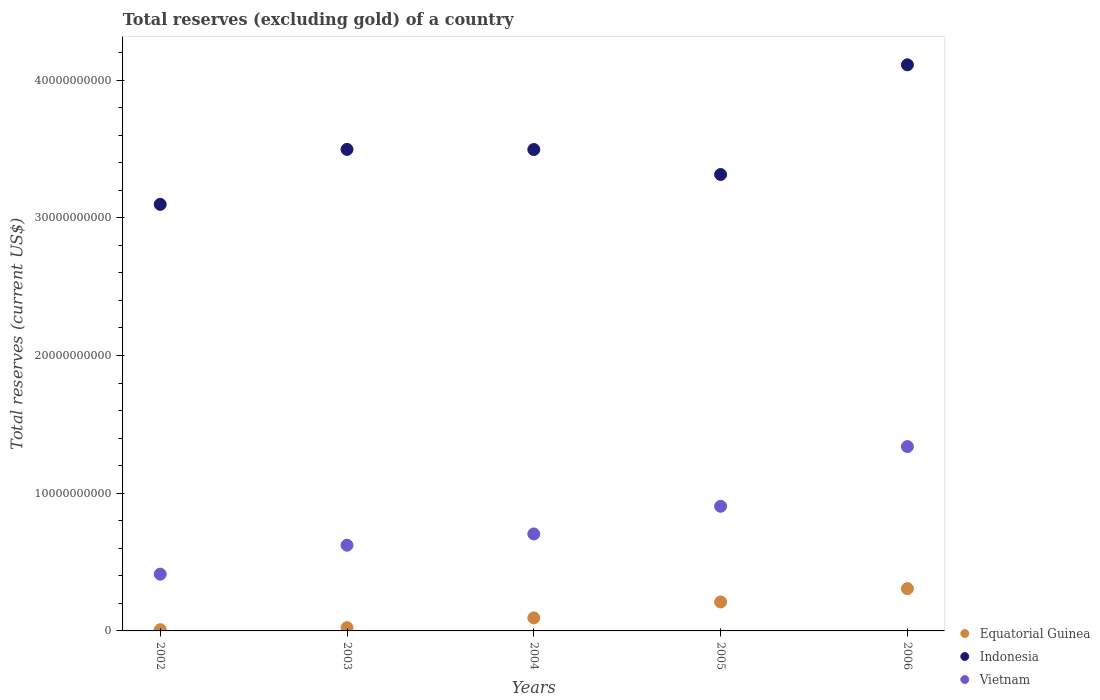How many different coloured dotlines are there?
Offer a terse response. 3. Is the number of dotlines equal to the number of legend labels?
Offer a terse response. Yes. What is the total reserves (excluding gold) in Vietnam in 2003?
Make the answer very short. 6.22e+09. Across all years, what is the maximum total reserves (excluding gold) in Equatorial Guinea?
Provide a succinct answer. 3.07e+09. Across all years, what is the minimum total reserves (excluding gold) in Vietnam?
Your answer should be very brief. 4.12e+09. What is the total total reserves (excluding gold) in Equatorial Guinea in the graph?
Offer a very short reply. 6.44e+09. What is the difference between the total reserves (excluding gold) in Indonesia in 2002 and that in 2004?
Ensure brevity in your answer.  -3.98e+09. What is the difference between the total reserves (excluding gold) in Vietnam in 2002 and the total reserves (excluding gold) in Equatorial Guinea in 2003?
Your response must be concise. 3.88e+09. What is the average total reserves (excluding gold) in Equatorial Guinea per year?
Offer a terse response. 1.29e+09. In the year 2003, what is the difference between the total reserves (excluding gold) in Vietnam and total reserves (excluding gold) in Equatorial Guinea?
Your answer should be very brief. 5.99e+09. In how many years, is the total reserves (excluding gold) in Vietnam greater than 4000000000 US$?
Offer a very short reply. 5. What is the ratio of the total reserves (excluding gold) in Equatorial Guinea in 2002 to that in 2003?
Provide a succinct answer. 0.37. Is the total reserves (excluding gold) in Equatorial Guinea in 2003 less than that in 2005?
Offer a terse response. Yes. What is the difference between the highest and the second highest total reserves (excluding gold) in Indonesia?
Ensure brevity in your answer.  6.14e+09. What is the difference between the highest and the lowest total reserves (excluding gold) in Equatorial Guinea?
Make the answer very short. 2.98e+09. In how many years, is the total reserves (excluding gold) in Equatorial Guinea greater than the average total reserves (excluding gold) in Equatorial Guinea taken over all years?
Give a very brief answer. 2. Is the sum of the total reserves (excluding gold) in Equatorial Guinea in 2002 and 2006 greater than the maximum total reserves (excluding gold) in Vietnam across all years?
Ensure brevity in your answer.  No. Is it the case that in every year, the sum of the total reserves (excluding gold) in Equatorial Guinea and total reserves (excluding gold) in Vietnam  is greater than the total reserves (excluding gold) in Indonesia?
Provide a short and direct response. No. Does the total reserves (excluding gold) in Vietnam monotonically increase over the years?
Give a very brief answer. Yes. Is the total reserves (excluding gold) in Equatorial Guinea strictly less than the total reserves (excluding gold) in Indonesia over the years?
Keep it short and to the point. Yes. How many years are there in the graph?
Give a very brief answer. 5. Are the values on the major ticks of Y-axis written in scientific E-notation?
Ensure brevity in your answer.  No. Does the graph contain any zero values?
Provide a succinct answer. No. Where does the legend appear in the graph?
Make the answer very short. Bottom right. How many legend labels are there?
Provide a succinct answer. 3. How are the legend labels stacked?
Provide a succinct answer. Vertical. What is the title of the graph?
Provide a succinct answer. Total reserves (excluding gold) of a country. What is the label or title of the X-axis?
Give a very brief answer. Years. What is the label or title of the Y-axis?
Give a very brief answer. Total reserves (current US$). What is the Total reserves (current US$) of Equatorial Guinea in 2002?
Provide a short and direct response. 8.85e+07. What is the Total reserves (current US$) in Indonesia in 2002?
Your response must be concise. 3.10e+1. What is the Total reserves (current US$) in Vietnam in 2002?
Your answer should be very brief. 4.12e+09. What is the Total reserves (current US$) of Equatorial Guinea in 2003?
Your answer should be very brief. 2.38e+08. What is the Total reserves (current US$) in Indonesia in 2003?
Offer a terse response. 3.50e+1. What is the Total reserves (current US$) in Vietnam in 2003?
Provide a succinct answer. 6.22e+09. What is the Total reserves (current US$) of Equatorial Guinea in 2004?
Keep it short and to the point. 9.45e+08. What is the Total reserves (current US$) in Indonesia in 2004?
Ensure brevity in your answer.  3.50e+1. What is the Total reserves (current US$) in Vietnam in 2004?
Keep it short and to the point. 7.04e+09. What is the Total reserves (current US$) in Equatorial Guinea in 2005?
Provide a succinct answer. 2.10e+09. What is the Total reserves (current US$) in Indonesia in 2005?
Make the answer very short. 3.31e+1. What is the Total reserves (current US$) in Vietnam in 2005?
Ensure brevity in your answer.  9.05e+09. What is the Total reserves (current US$) of Equatorial Guinea in 2006?
Give a very brief answer. 3.07e+09. What is the Total reserves (current US$) of Indonesia in 2006?
Provide a short and direct response. 4.11e+1. What is the Total reserves (current US$) in Vietnam in 2006?
Provide a succinct answer. 1.34e+1. Across all years, what is the maximum Total reserves (current US$) in Equatorial Guinea?
Make the answer very short. 3.07e+09. Across all years, what is the maximum Total reserves (current US$) in Indonesia?
Your answer should be very brief. 4.11e+1. Across all years, what is the maximum Total reserves (current US$) of Vietnam?
Keep it short and to the point. 1.34e+1. Across all years, what is the minimum Total reserves (current US$) in Equatorial Guinea?
Your response must be concise. 8.85e+07. Across all years, what is the minimum Total reserves (current US$) of Indonesia?
Offer a very short reply. 3.10e+1. Across all years, what is the minimum Total reserves (current US$) in Vietnam?
Provide a short and direct response. 4.12e+09. What is the total Total reserves (current US$) in Equatorial Guinea in the graph?
Offer a very short reply. 6.44e+09. What is the total Total reserves (current US$) of Indonesia in the graph?
Provide a succinct answer. 1.75e+11. What is the total Total reserves (current US$) of Vietnam in the graph?
Offer a terse response. 3.98e+1. What is the difference between the Total reserves (current US$) of Equatorial Guinea in 2002 and that in 2003?
Give a very brief answer. -1.49e+08. What is the difference between the Total reserves (current US$) of Indonesia in 2002 and that in 2003?
Your answer should be very brief. -3.99e+09. What is the difference between the Total reserves (current US$) of Vietnam in 2002 and that in 2003?
Your answer should be compact. -2.10e+09. What is the difference between the Total reserves (current US$) of Equatorial Guinea in 2002 and that in 2004?
Keep it short and to the point. -8.56e+08. What is the difference between the Total reserves (current US$) in Indonesia in 2002 and that in 2004?
Provide a succinct answer. -3.98e+09. What is the difference between the Total reserves (current US$) in Vietnam in 2002 and that in 2004?
Give a very brief answer. -2.92e+09. What is the difference between the Total reserves (current US$) of Equatorial Guinea in 2002 and that in 2005?
Give a very brief answer. -2.01e+09. What is the difference between the Total reserves (current US$) of Indonesia in 2002 and that in 2005?
Give a very brief answer. -2.17e+09. What is the difference between the Total reserves (current US$) in Vietnam in 2002 and that in 2005?
Keep it short and to the point. -4.93e+09. What is the difference between the Total reserves (current US$) in Equatorial Guinea in 2002 and that in 2006?
Offer a very short reply. -2.98e+09. What is the difference between the Total reserves (current US$) in Indonesia in 2002 and that in 2006?
Provide a short and direct response. -1.01e+1. What is the difference between the Total reserves (current US$) of Vietnam in 2002 and that in 2006?
Make the answer very short. -9.26e+09. What is the difference between the Total reserves (current US$) in Equatorial Guinea in 2003 and that in 2004?
Make the answer very short. -7.07e+08. What is the difference between the Total reserves (current US$) in Indonesia in 2003 and that in 2004?
Offer a terse response. 9.82e+06. What is the difference between the Total reserves (current US$) in Vietnam in 2003 and that in 2004?
Keep it short and to the point. -8.17e+08. What is the difference between the Total reserves (current US$) in Equatorial Guinea in 2003 and that in 2005?
Offer a very short reply. -1.86e+09. What is the difference between the Total reserves (current US$) in Indonesia in 2003 and that in 2005?
Offer a very short reply. 1.82e+09. What is the difference between the Total reserves (current US$) of Vietnam in 2003 and that in 2005?
Make the answer very short. -2.83e+09. What is the difference between the Total reserves (current US$) of Equatorial Guinea in 2003 and that in 2006?
Keep it short and to the point. -2.83e+09. What is the difference between the Total reserves (current US$) of Indonesia in 2003 and that in 2006?
Make the answer very short. -6.14e+09. What is the difference between the Total reserves (current US$) in Vietnam in 2003 and that in 2006?
Ensure brevity in your answer.  -7.16e+09. What is the difference between the Total reserves (current US$) of Equatorial Guinea in 2004 and that in 2005?
Keep it short and to the point. -1.16e+09. What is the difference between the Total reserves (current US$) in Indonesia in 2004 and that in 2005?
Offer a terse response. 1.81e+09. What is the difference between the Total reserves (current US$) in Vietnam in 2004 and that in 2005?
Keep it short and to the point. -2.01e+09. What is the difference between the Total reserves (current US$) of Equatorial Guinea in 2004 and that in 2006?
Provide a short and direct response. -2.12e+09. What is the difference between the Total reserves (current US$) in Indonesia in 2004 and that in 2006?
Ensure brevity in your answer.  -6.15e+09. What is the difference between the Total reserves (current US$) of Vietnam in 2004 and that in 2006?
Make the answer very short. -6.34e+09. What is the difference between the Total reserves (current US$) in Equatorial Guinea in 2005 and that in 2006?
Offer a terse response. -9.64e+08. What is the difference between the Total reserves (current US$) in Indonesia in 2005 and that in 2006?
Your answer should be compact. -7.96e+09. What is the difference between the Total reserves (current US$) in Vietnam in 2005 and that in 2006?
Provide a succinct answer. -4.33e+09. What is the difference between the Total reserves (current US$) in Equatorial Guinea in 2002 and the Total reserves (current US$) in Indonesia in 2003?
Ensure brevity in your answer.  -3.49e+1. What is the difference between the Total reserves (current US$) of Equatorial Guinea in 2002 and the Total reserves (current US$) of Vietnam in 2003?
Keep it short and to the point. -6.14e+09. What is the difference between the Total reserves (current US$) of Indonesia in 2002 and the Total reserves (current US$) of Vietnam in 2003?
Your response must be concise. 2.47e+1. What is the difference between the Total reserves (current US$) of Equatorial Guinea in 2002 and the Total reserves (current US$) of Indonesia in 2004?
Provide a short and direct response. -3.49e+1. What is the difference between the Total reserves (current US$) of Equatorial Guinea in 2002 and the Total reserves (current US$) of Vietnam in 2004?
Provide a short and direct response. -6.95e+09. What is the difference between the Total reserves (current US$) in Indonesia in 2002 and the Total reserves (current US$) in Vietnam in 2004?
Your response must be concise. 2.39e+1. What is the difference between the Total reserves (current US$) of Equatorial Guinea in 2002 and the Total reserves (current US$) of Indonesia in 2005?
Offer a very short reply. -3.31e+1. What is the difference between the Total reserves (current US$) in Equatorial Guinea in 2002 and the Total reserves (current US$) in Vietnam in 2005?
Provide a short and direct response. -8.96e+09. What is the difference between the Total reserves (current US$) of Indonesia in 2002 and the Total reserves (current US$) of Vietnam in 2005?
Provide a succinct answer. 2.19e+1. What is the difference between the Total reserves (current US$) in Equatorial Guinea in 2002 and the Total reserves (current US$) in Indonesia in 2006?
Make the answer very short. -4.10e+1. What is the difference between the Total reserves (current US$) in Equatorial Guinea in 2002 and the Total reserves (current US$) in Vietnam in 2006?
Your answer should be very brief. -1.33e+1. What is the difference between the Total reserves (current US$) of Indonesia in 2002 and the Total reserves (current US$) of Vietnam in 2006?
Give a very brief answer. 1.76e+1. What is the difference between the Total reserves (current US$) of Equatorial Guinea in 2003 and the Total reserves (current US$) of Indonesia in 2004?
Provide a short and direct response. -3.47e+1. What is the difference between the Total reserves (current US$) of Equatorial Guinea in 2003 and the Total reserves (current US$) of Vietnam in 2004?
Keep it short and to the point. -6.80e+09. What is the difference between the Total reserves (current US$) of Indonesia in 2003 and the Total reserves (current US$) of Vietnam in 2004?
Give a very brief answer. 2.79e+1. What is the difference between the Total reserves (current US$) in Equatorial Guinea in 2003 and the Total reserves (current US$) in Indonesia in 2005?
Give a very brief answer. -3.29e+1. What is the difference between the Total reserves (current US$) in Equatorial Guinea in 2003 and the Total reserves (current US$) in Vietnam in 2005?
Offer a terse response. -8.81e+09. What is the difference between the Total reserves (current US$) in Indonesia in 2003 and the Total reserves (current US$) in Vietnam in 2005?
Keep it short and to the point. 2.59e+1. What is the difference between the Total reserves (current US$) of Equatorial Guinea in 2003 and the Total reserves (current US$) of Indonesia in 2006?
Provide a short and direct response. -4.09e+1. What is the difference between the Total reserves (current US$) in Equatorial Guinea in 2003 and the Total reserves (current US$) in Vietnam in 2006?
Make the answer very short. -1.31e+1. What is the difference between the Total reserves (current US$) of Indonesia in 2003 and the Total reserves (current US$) of Vietnam in 2006?
Keep it short and to the point. 2.16e+1. What is the difference between the Total reserves (current US$) in Equatorial Guinea in 2004 and the Total reserves (current US$) in Indonesia in 2005?
Provide a short and direct response. -3.22e+1. What is the difference between the Total reserves (current US$) of Equatorial Guinea in 2004 and the Total reserves (current US$) of Vietnam in 2005?
Offer a terse response. -8.11e+09. What is the difference between the Total reserves (current US$) of Indonesia in 2004 and the Total reserves (current US$) of Vietnam in 2005?
Make the answer very short. 2.59e+1. What is the difference between the Total reserves (current US$) in Equatorial Guinea in 2004 and the Total reserves (current US$) in Indonesia in 2006?
Ensure brevity in your answer.  -4.02e+1. What is the difference between the Total reserves (current US$) of Equatorial Guinea in 2004 and the Total reserves (current US$) of Vietnam in 2006?
Offer a very short reply. -1.24e+1. What is the difference between the Total reserves (current US$) in Indonesia in 2004 and the Total reserves (current US$) in Vietnam in 2006?
Provide a short and direct response. 2.16e+1. What is the difference between the Total reserves (current US$) in Equatorial Guinea in 2005 and the Total reserves (current US$) in Indonesia in 2006?
Provide a short and direct response. -3.90e+1. What is the difference between the Total reserves (current US$) in Equatorial Guinea in 2005 and the Total reserves (current US$) in Vietnam in 2006?
Your response must be concise. -1.13e+1. What is the difference between the Total reserves (current US$) in Indonesia in 2005 and the Total reserves (current US$) in Vietnam in 2006?
Your response must be concise. 1.98e+1. What is the average Total reserves (current US$) of Equatorial Guinea per year?
Keep it short and to the point. 1.29e+09. What is the average Total reserves (current US$) of Indonesia per year?
Keep it short and to the point. 3.50e+1. What is the average Total reserves (current US$) of Vietnam per year?
Offer a very short reply. 7.96e+09. In the year 2002, what is the difference between the Total reserves (current US$) in Equatorial Guinea and Total reserves (current US$) in Indonesia?
Give a very brief answer. -3.09e+1. In the year 2002, what is the difference between the Total reserves (current US$) of Equatorial Guinea and Total reserves (current US$) of Vietnam?
Provide a short and direct response. -4.03e+09. In the year 2002, what is the difference between the Total reserves (current US$) of Indonesia and Total reserves (current US$) of Vietnam?
Make the answer very short. 2.68e+1. In the year 2003, what is the difference between the Total reserves (current US$) of Equatorial Guinea and Total reserves (current US$) of Indonesia?
Provide a short and direct response. -3.47e+1. In the year 2003, what is the difference between the Total reserves (current US$) in Equatorial Guinea and Total reserves (current US$) in Vietnam?
Offer a terse response. -5.99e+09. In the year 2003, what is the difference between the Total reserves (current US$) in Indonesia and Total reserves (current US$) in Vietnam?
Your response must be concise. 2.87e+1. In the year 2004, what is the difference between the Total reserves (current US$) of Equatorial Guinea and Total reserves (current US$) of Indonesia?
Provide a succinct answer. -3.40e+1. In the year 2004, what is the difference between the Total reserves (current US$) in Equatorial Guinea and Total reserves (current US$) in Vietnam?
Offer a very short reply. -6.10e+09. In the year 2004, what is the difference between the Total reserves (current US$) in Indonesia and Total reserves (current US$) in Vietnam?
Your response must be concise. 2.79e+1. In the year 2005, what is the difference between the Total reserves (current US$) of Equatorial Guinea and Total reserves (current US$) of Indonesia?
Provide a short and direct response. -3.10e+1. In the year 2005, what is the difference between the Total reserves (current US$) in Equatorial Guinea and Total reserves (current US$) in Vietnam?
Your response must be concise. -6.95e+09. In the year 2005, what is the difference between the Total reserves (current US$) in Indonesia and Total reserves (current US$) in Vietnam?
Your answer should be very brief. 2.41e+1. In the year 2006, what is the difference between the Total reserves (current US$) of Equatorial Guinea and Total reserves (current US$) of Indonesia?
Offer a very short reply. -3.80e+1. In the year 2006, what is the difference between the Total reserves (current US$) of Equatorial Guinea and Total reserves (current US$) of Vietnam?
Your response must be concise. -1.03e+1. In the year 2006, what is the difference between the Total reserves (current US$) in Indonesia and Total reserves (current US$) in Vietnam?
Your answer should be compact. 2.77e+1. What is the ratio of the Total reserves (current US$) in Equatorial Guinea in 2002 to that in 2003?
Make the answer very short. 0.37. What is the ratio of the Total reserves (current US$) of Indonesia in 2002 to that in 2003?
Provide a succinct answer. 0.89. What is the ratio of the Total reserves (current US$) in Vietnam in 2002 to that in 2003?
Provide a short and direct response. 0.66. What is the ratio of the Total reserves (current US$) in Equatorial Guinea in 2002 to that in 2004?
Offer a terse response. 0.09. What is the ratio of the Total reserves (current US$) in Indonesia in 2002 to that in 2004?
Offer a very short reply. 0.89. What is the ratio of the Total reserves (current US$) in Vietnam in 2002 to that in 2004?
Give a very brief answer. 0.59. What is the ratio of the Total reserves (current US$) in Equatorial Guinea in 2002 to that in 2005?
Make the answer very short. 0.04. What is the ratio of the Total reserves (current US$) of Indonesia in 2002 to that in 2005?
Keep it short and to the point. 0.93. What is the ratio of the Total reserves (current US$) in Vietnam in 2002 to that in 2005?
Give a very brief answer. 0.46. What is the ratio of the Total reserves (current US$) of Equatorial Guinea in 2002 to that in 2006?
Your answer should be compact. 0.03. What is the ratio of the Total reserves (current US$) of Indonesia in 2002 to that in 2006?
Provide a short and direct response. 0.75. What is the ratio of the Total reserves (current US$) in Vietnam in 2002 to that in 2006?
Ensure brevity in your answer.  0.31. What is the ratio of the Total reserves (current US$) of Equatorial Guinea in 2003 to that in 2004?
Provide a succinct answer. 0.25. What is the ratio of the Total reserves (current US$) in Vietnam in 2003 to that in 2004?
Ensure brevity in your answer.  0.88. What is the ratio of the Total reserves (current US$) of Equatorial Guinea in 2003 to that in 2005?
Provide a succinct answer. 0.11. What is the ratio of the Total reserves (current US$) in Indonesia in 2003 to that in 2005?
Your answer should be very brief. 1.05. What is the ratio of the Total reserves (current US$) in Vietnam in 2003 to that in 2005?
Your answer should be very brief. 0.69. What is the ratio of the Total reserves (current US$) of Equatorial Guinea in 2003 to that in 2006?
Your response must be concise. 0.08. What is the ratio of the Total reserves (current US$) of Indonesia in 2003 to that in 2006?
Offer a very short reply. 0.85. What is the ratio of the Total reserves (current US$) in Vietnam in 2003 to that in 2006?
Your answer should be very brief. 0.47. What is the ratio of the Total reserves (current US$) in Equatorial Guinea in 2004 to that in 2005?
Your response must be concise. 0.45. What is the ratio of the Total reserves (current US$) of Indonesia in 2004 to that in 2005?
Your answer should be very brief. 1.05. What is the ratio of the Total reserves (current US$) in Vietnam in 2004 to that in 2005?
Make the answer very short. 0.78. What is the ratio of the Total reserves (current US$) in Equatorial Guinea in 2004 to that in 2006?
Provide a short and direct response. 0.31. What is the ratio of the Total reserves (current US$) in Indonesia in 2004 to that in 2006?
Give a very brief answer. 0.85. What is the ratio of the Total reserves (current US$) in Vietnam in 2004 to that in 2006?
Offer a very short reply. 0.53. What is the ratio of the Total reserves (current US$) in Equatorial Guinea in 2005 to that in 2006?
Keep it short and to the point. 0.69. What is the ratio of the Total reserves (current US$) in Indonesia in 2005 to that in 2006?
Ensure brevity in your answer.  0.81. What is the ratio of the Total reserves (current US$) of Vietnam in 2005 to that in 2006?
Ensure brevity in your answer.  0.68. What is the difference between the highest and the second highest Total reserves (current US$) in Equatorial Guinea?
Your answer should be very brief. 9.64e+08. What is the difference between the highest and the second highest Total reserves (current US$) in Indonesia?
Keep it short and to the point. 6.14e+09. What is the difference between the highest and the second highest Total reserves (current US$) in Vietnam?
Ensure brevity in your answer.  4.33e+09. What is the difference between the highest and the lowest Total reserves (current US$) in Equatorial Guinea?
Give a very brief answer. 2.98e+09. What is the difference between the highest and the lowest Total reserves (current US$) of Indonesia?
Ensure brevity in your answer.  1.01e+1. What is the difference between the highest and the lowest Total reserves (current US$) in Vietnam?
Ensure brevity in your answer.  9.26e+09. 